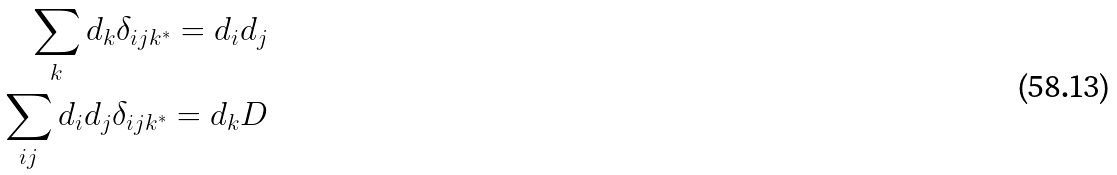<formula> <loc_0><loc_0><loc_500><loc_500>\sum _ { k } d _ { k } \delta _ { i j k ^ { * } } = d _ { i } d _ { j } \\ \sum _ { i j } d _ { i } d _ { j } \delta _ { i j k ^ { * } } = d _ { k } D</formula> 